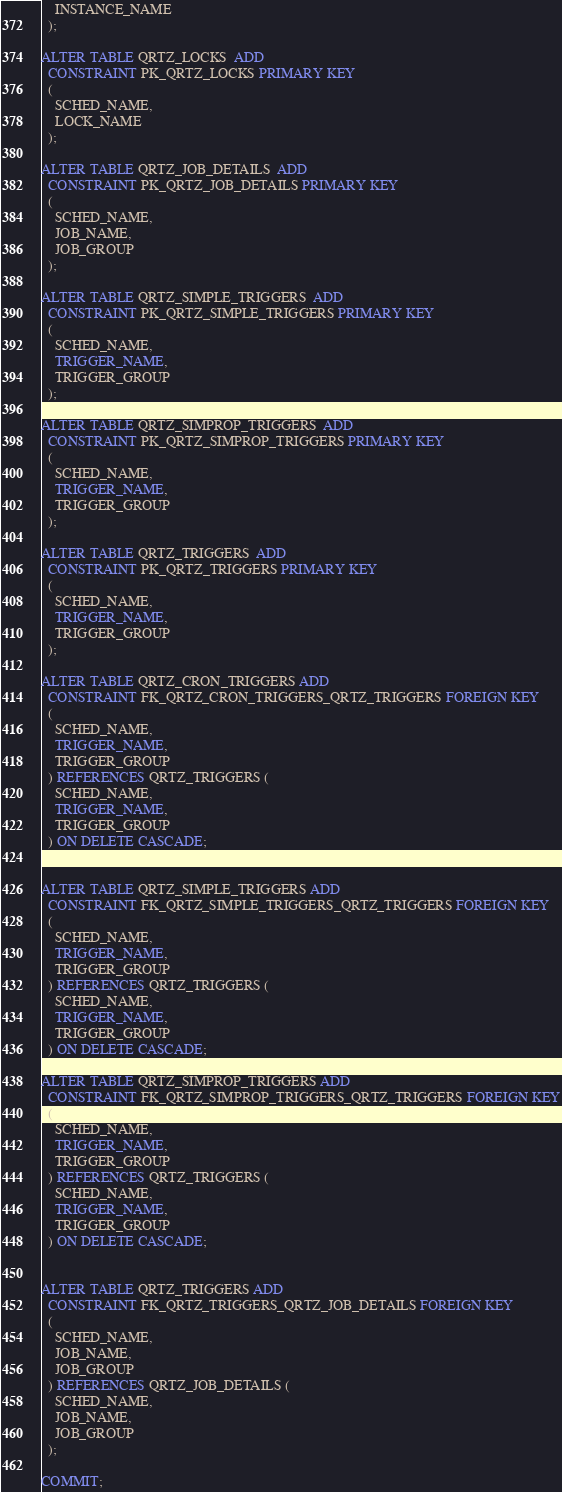Convert code to text. <code><loc_0><loc_0><loc_500><loc_500><_SQL_>    INSTANCE_NAME
  );

ALTER TABLE QRTZ_LOCKS  ADD
  CONSTRAINT PK_QRTZ_LOCKS PRIMARY KEY  
  (
    SCHED_NAME,
    LOCK_NAME
  );

ALTER TABLE QRTZ_JOB_DETAILS  ADD
  CONSTRAINT PK_QRTZ_JOB_DETAILS PRIMARY KEY  
  (
    SCHED_NAME,
    JOB_NAME,
    JOB_GROUP
  );

ALTER TABLE QRTZ_SIMPLE_TRIGGERS  ADD
  CONSTRAINT PK_QRTZ_SIMPLE_TRIGGERS PRIMARY KEY  
  (
    SCHED_NAME,
    TRIGGER_NAME,
    TRIGGER_GROUP
  );

ALTER TABLE QRTZ_SIMPROP_TRIGGERS  ADD
  CONSTRAINT PK_QRTZ_SIMPROP_TRIGGERS PRIMARY KEY  
  (
    SCHED_NAME,
    TRIGGER_NAME,
    TRIGGER_GROUP
  );

ALTER TABLE QRTZ_TRIGGERS  ADD
  CONSTRAINT PK_QRTZ_TRIGGERS PRIMARY KEY  
  (
    SCHED_NAME,
    TRIGGER_NAME,
    TRIGGER_GROUP
  );

ALTER TABLE QRTZ_CRON_TRIGGERS ADD
  CONSTRAINT FK_QRTZ_CRON_TRIGGERS_QRTZ_TRIGGERS FOREIGN KEY
  (
    SCHED_NAME,
    TRIGGER_NAME,
    TRIGGER_GROUP
  ) REFERENCES QRTZ_TRIGGERS (
    SCHED_NAME,
    TRIGGER_NAME,
    TRIGGER_GROUP
  ) ON DELETE CASCADE;


ALTER TABLE QRTZ_SIMPLE_TRIGGERS ADD
  CONSTRAINT FK_QRTZ_SIMPLE_TRIGGERS_QRTZ_TRIGGERS FOREIGN KEY
  (
    SCHED_NAME,
    TRIGGER_NAME,
    TRIGGER_GROUP
  ) REFERENCES QRTZ_TRIGGERS (
    SCHED_NAME,
    TRIGGER_NAME,
    TRIGGER_GROUP
  ) ON DELETE CASCADE;

ALTER TABLE QRTZ_SIMPROP_TRIGGERS ADD
  CONSTRAINT FK_QRTZ_SIMPROP_TRIGGERS_QRTZ_TRIGGERS FOREIGN KEY
  (
    SCHED_NAME,
    TRIGGER_NAME,
    TRIGGER_GROUP
  ) REFERENCES QRTZ_TRIGGERS (
    SCHED_NAME,
    TRIGGER_NAME,
    TRIGGER_GROUP
  ) ON DELETE CASCADE;


ALTER TABLE QRTZ_TRIGGERS ADD
  CONSTRAINT FK_QRTZ_TRIGGERS_QRTZ_JOB_DETAILS FOREIGN KEY
  (
    SCHED_NAME,
    JOB_NAME,
    JOB_GROUP
  ) REFERENCES QRTZ_JOB_DETAILS (
    SCHED_NAME,
    JOB_NAME,
    JOB_GROUP
  );
  
COMMIT;
</code> 